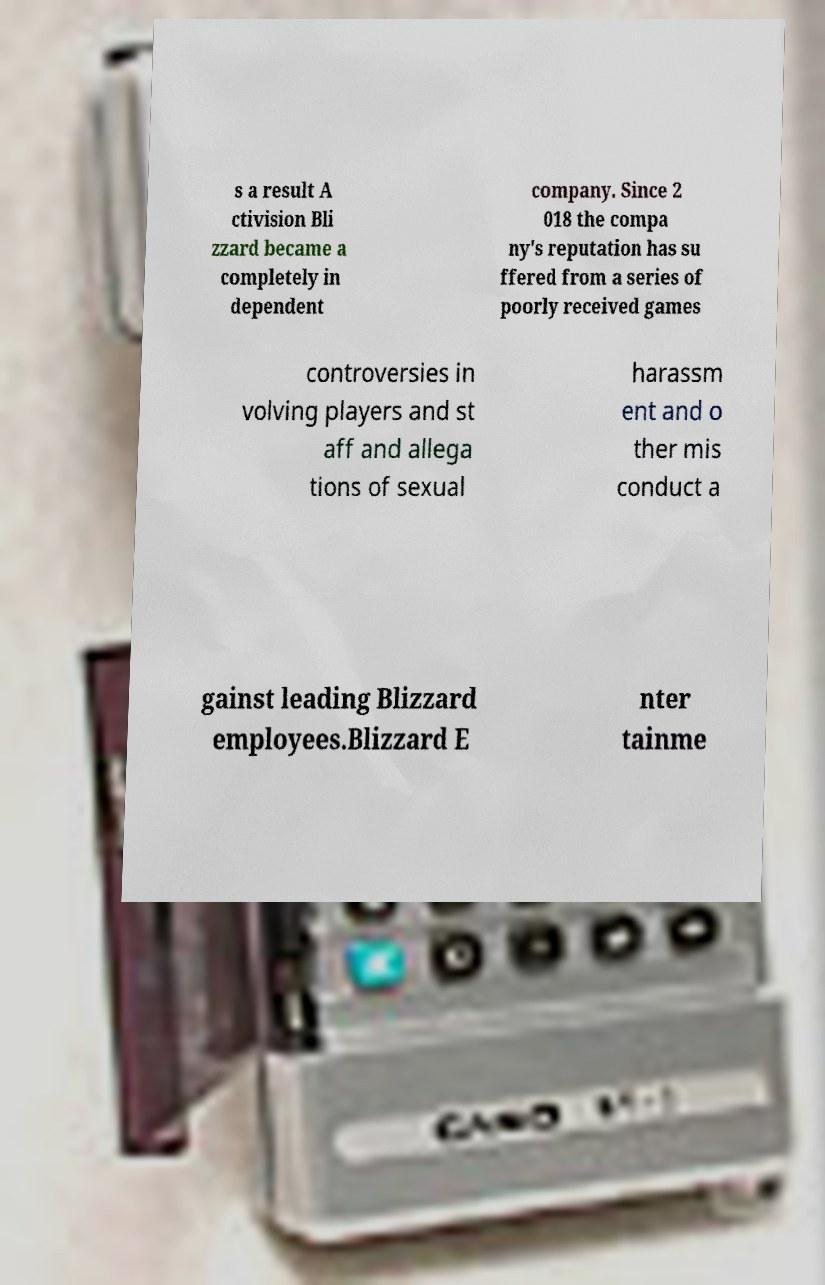Can you read and provide the text displayed in the image?This photo seems to have some interesting text. Can you extract and type it out for me? s a result A ctivision Bli zzard became a completely in dependent company. Since 2 018 the compa ny's reputation has su ffered from a series of poorly received games controversies in volving players and st aff and allega tions of sexual harassm ent and o ther mis conduct a gainst leading Blizzard employees.Blizzard E nter tainme 